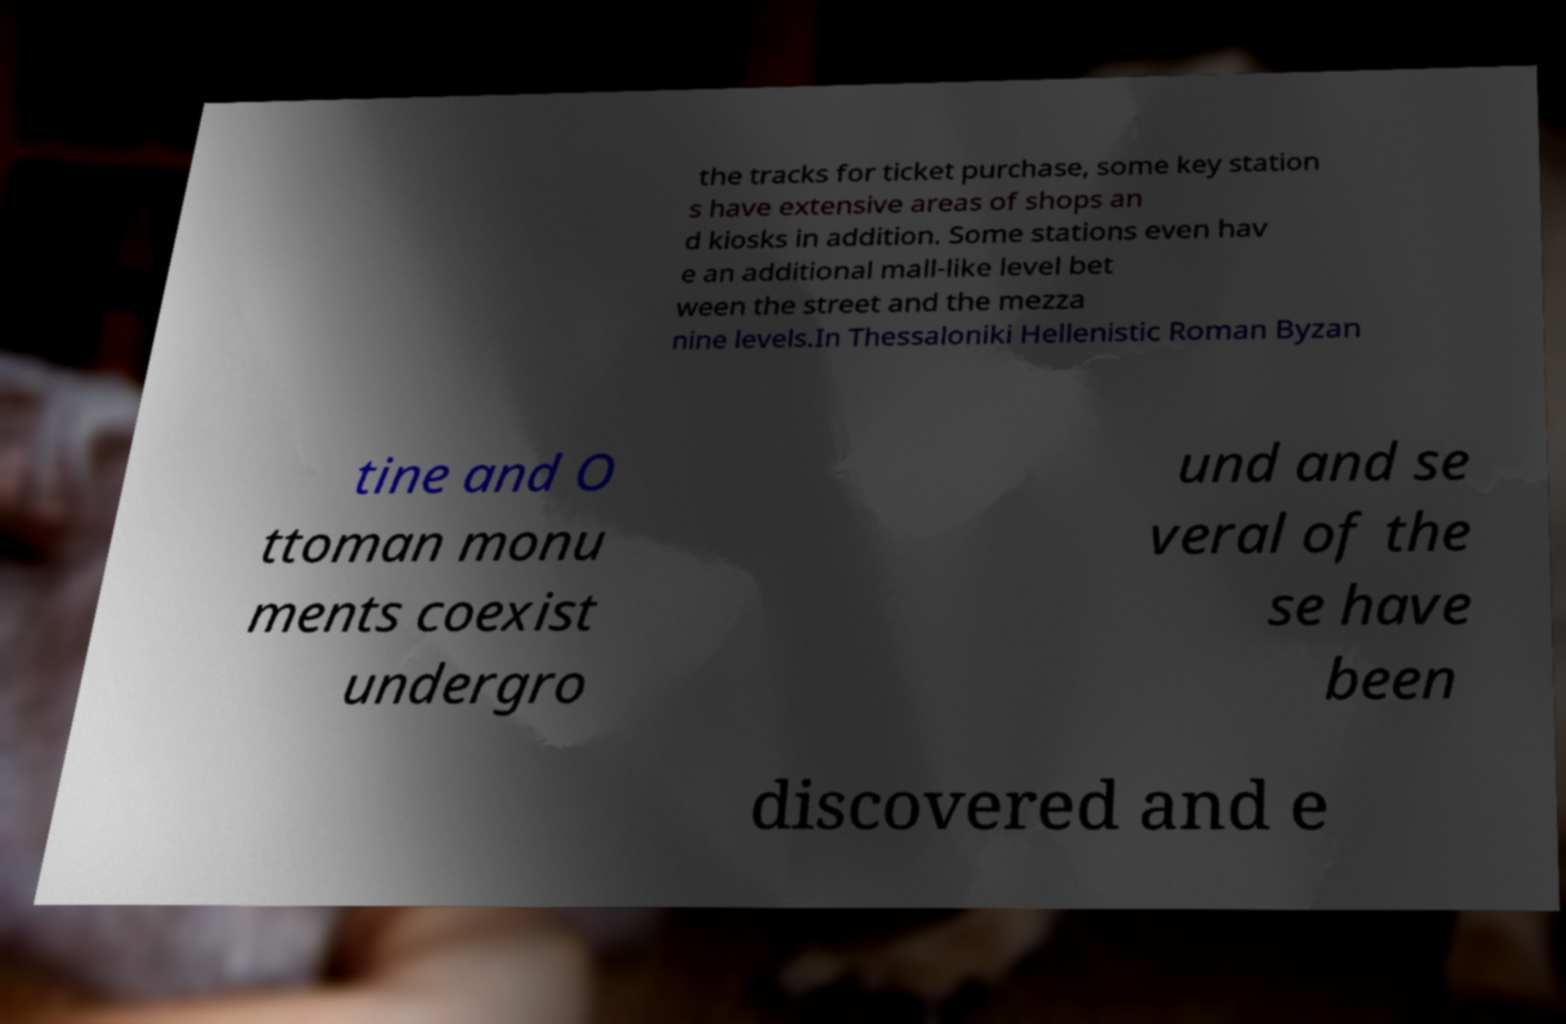There's text embedded in this image that I need extracted. Can you transcribe it verbatim? the tracks for ticket purchase, some key station s have extensive areas of shops an d kiosks in addition. Some stations even hav e an additional mall-like level bet ween the street and the mezza nine levels.In Thessaloniki Hellenistic Roman Byzan tine and O ttoman monu ments coexist undergro und and se veral of the se have been discovered and e 